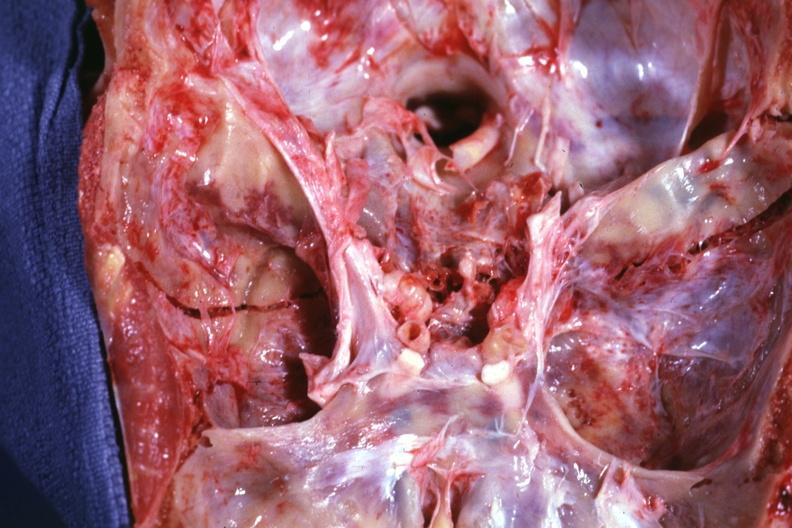what is present?
Answer the question using a single word or phrase. Bone, calvarium 